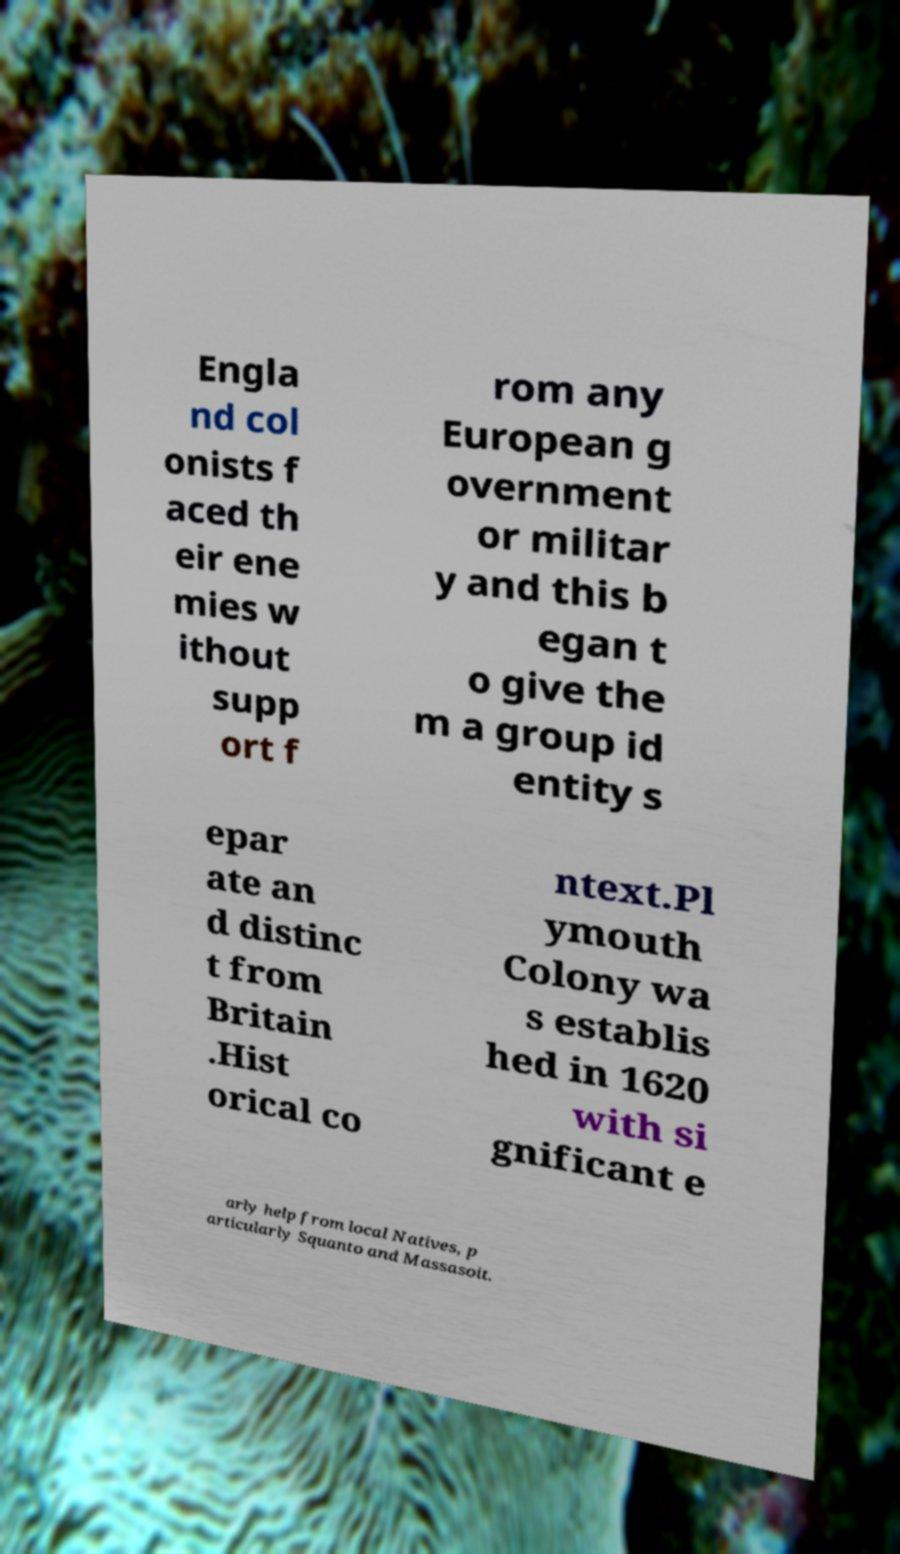Please identify and transcribe the text found in this image. Engla nd col onists f aced th eir ene mies w ithout supp ort f rom any European g overnment or militar y and this b egan t o give the m a group id entity s epar ate an d distinc t from Britain .Hist orical co ntext.Pl ymouth Colony wa s establis hed in 1620 with si gnificant e arly help from local Natives, p articularly Squanto and Massasoit. 